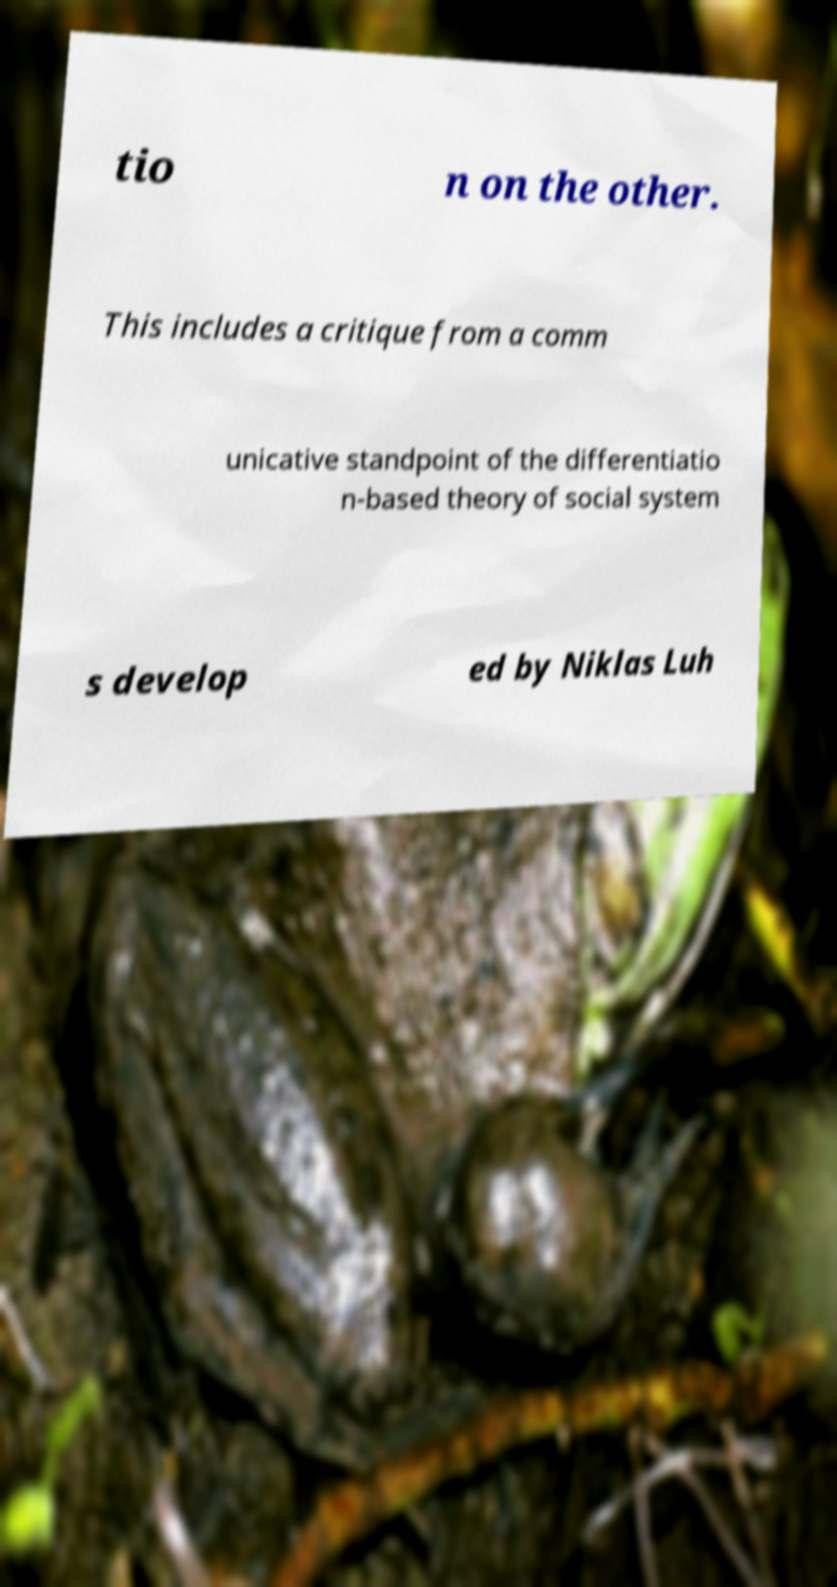Could you assist in decoding the text presented in this image and type it out clearly? tio n on the other. This includes a critique from a comm unicative standpoint of the differentiatio n-based theory of social system s develop ed by Niklas Luh 